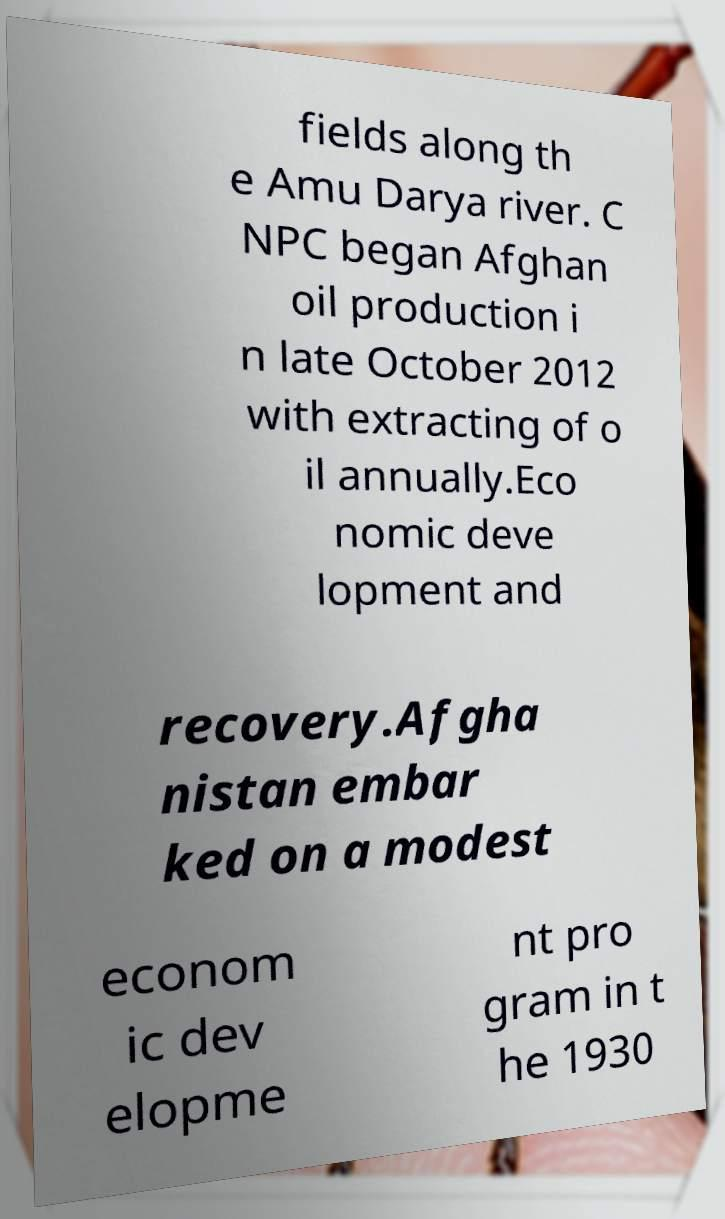Could you extract and type out the text from this image? fields along th e Amu Darya river. C NPC began Afghan oil production i n late October 2012 with extracting of o il annually.Eco nomic deve lopment and recovery.Afgha nistan embar ked on a modest econom ic dev elopme nt pro gram in t he 1930 